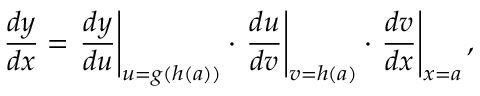Convert formula to latex. <formula><loc_0><loc_0><loc_500><loc_500>{ \frac { d y } { d x } } = { \frac { d y } { d u } } \right | _ { u = g ( h ( a ) ) } \cdot { \frac { d u } { d v } } \right | _ { v = h ( a ) } \cdot { \frac { d v } { d x } } \right | _ { x = a } ,</formula> 